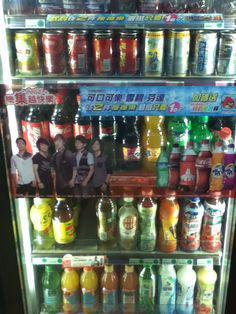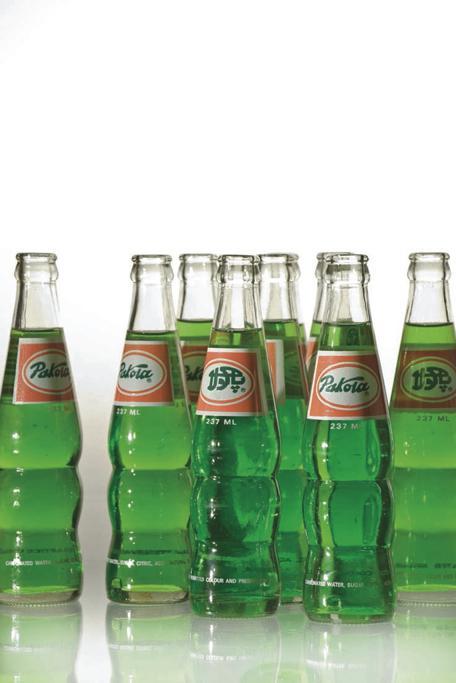The first image is the image on the left, the second image is the image on the right. Assess this claim about the two images: "All the bottles are full.". Correct or not? Answer yes or no. Yes. The first image is the image on the left, the second image is the image on the right. For the images displayed, is the sentence "Some of the soda bottles are in plastic crates." factually correct? Answer yes or no. No. 